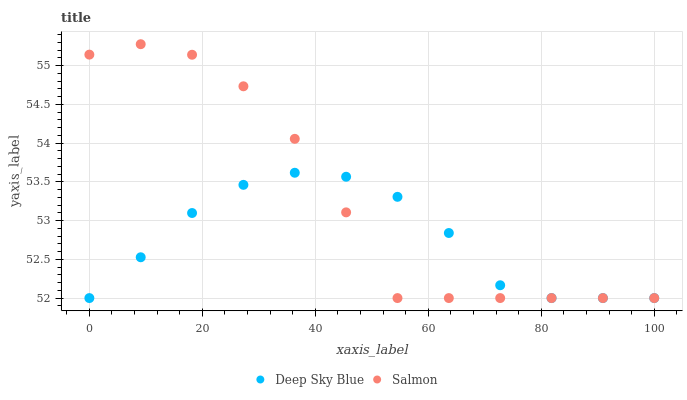Does Deep Sky Blue have the minimum area under the curve?
Answer yes or no. Yes. Does Salmon have the maximum area under the curve?
Answer yes or no. Yes. Does Deep Sky Blue have the maximum area under the curve?
Answer yes or no. No. Is Deep Sky Blue the smoothest?
Answer yes or no. Yes. Is Salmon the roughest?
Answer yes or no. Yes. Is Deep Sky Blue the roughest?
Answer yes or no. No. Does Salmon have the lowest value?
Answer yes or no. Yes. Does Salmon have the highest value?
Answer yes or no. Yes. Does Deep Sky Blue have the highest value?
Answer yes or no. No. Does Deep Sky Blue intersect Salmon?
Answer yes or no. Yes. Is Deep Sky Blue less than Salmon?
Answer yes or no. No. Is Deep Sky Blue greater than Salmon?
Answer yes or no. No. 